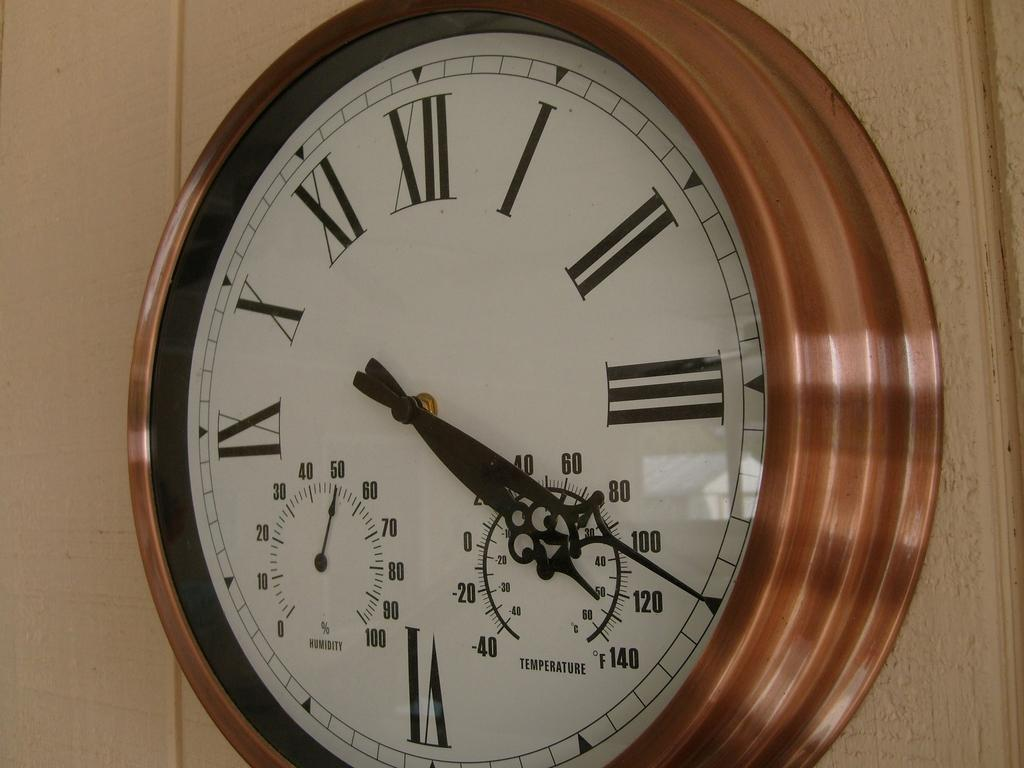What object is present in the image that is used for telling time? There is a clock in the image. Where is the clock positioned in the image? The clock is hanging on the wall. Can you describe the location of the clock in relation to the image? The clock is located in the center of the image. What type of badge can be seen on the clock in the image? There is no badge present on the clock in the image. Are there any bats flying around the clock in the image? There are no bats present in the image. 